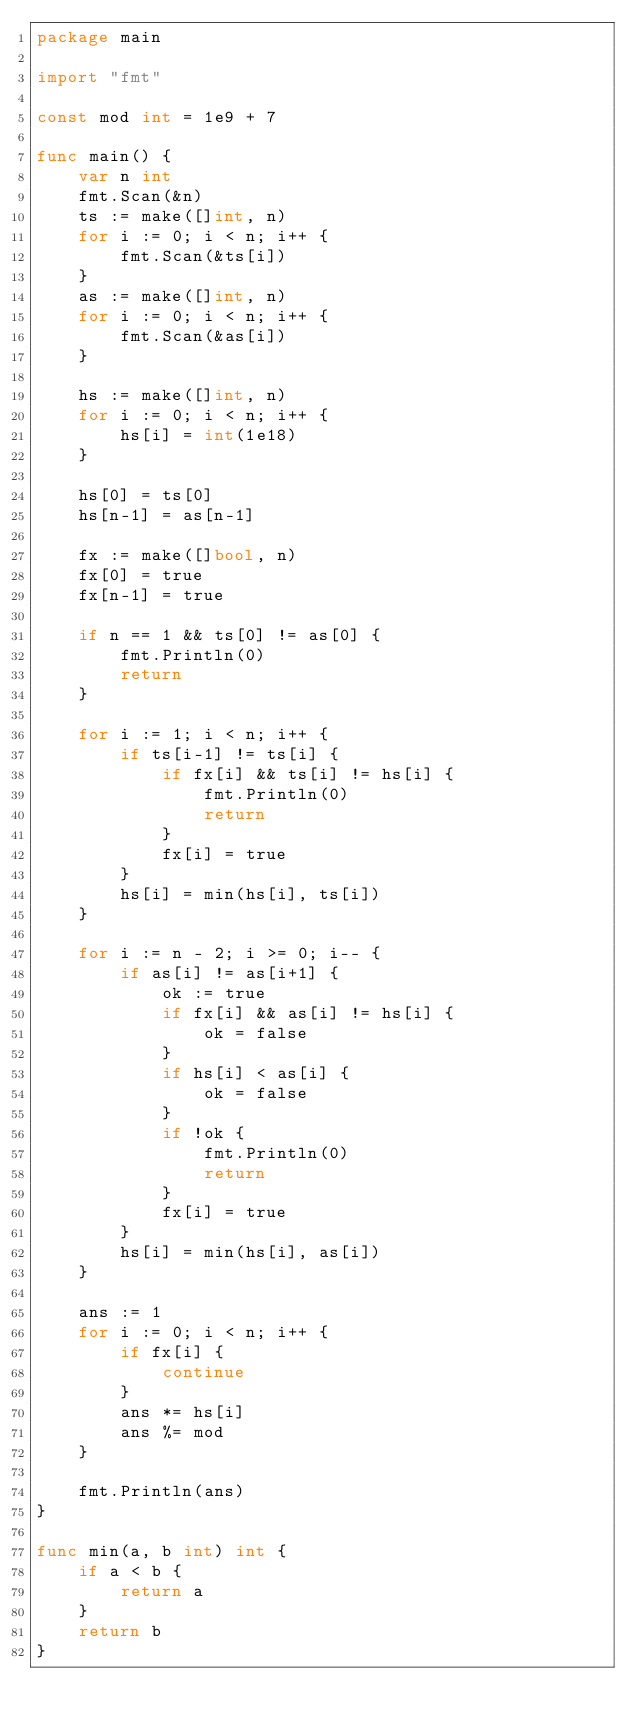Convert code to text. <code><loc_0><loc_0><loc_500><loc_500><_Go_>package main

import "fmt"

const mod int = 1e9 + 7

func main() {
	var n int
	fmt.Scan(&n)
	ts := make([]int, n)
	for i := 0; i < n; i++ {
		fmt.Scan(&ts[i])
	}
	as := make([]int, n)
	for i := 0; i < n; i++ {
		fmt.Scan(&as[i])
	}

	hs := make([]int, n)
	for i := 0; i < n; i++ {
		hs[i] = int(1e18)
	}

	hs[0] = ts[0]
	hs[n-1] = as[n-1]

	fx := make([]bool, n)
	fx[0] = true
	fx[n-1] = true

	if n == 1 && ts[0] != as[0] {
		fmt.Println(0)
		return
	}

	for i := 1; i < n; i++ {
		if ts[i-1] != ts[i] {
			if fx[i] && ts[i] != hs[i] {
				fmt.Println(0)
				return
			}
			fx[i] = true
		}
		hs[i] = min(hs[i], ts[i])
	}

	for i := n - 2; i >= 0; i-- {
		if as[i] != as[i+1] {
			ok := true
			if fx[i] && as[i] != hs[i] {
				ok = false
			}
			if hs[i] < as[i] {
				ok = false
			}
			if !ok {
				fmt.Println(0)
				return
			}
			fx[i] = true
		}
		hs[i] = min(hs[i], as[i])
	}

	ans := 1
	for i := 0; i < n; i++ {
		if fx[i] {
			continue
		}
		ans *= hs[i]
		ans %= mod
	}

	fmt.Println(ans)
}

func min(a, b int) int {
	if a < b {
		return a
	}
	return b
}
</code> 